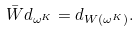<formula> <loc_0><loc_0><loc_500><loc_500>\bar { W } d _ { \omega ^ { K } } = d _ { W ( \omega ^ { K } ) } .</formula> 